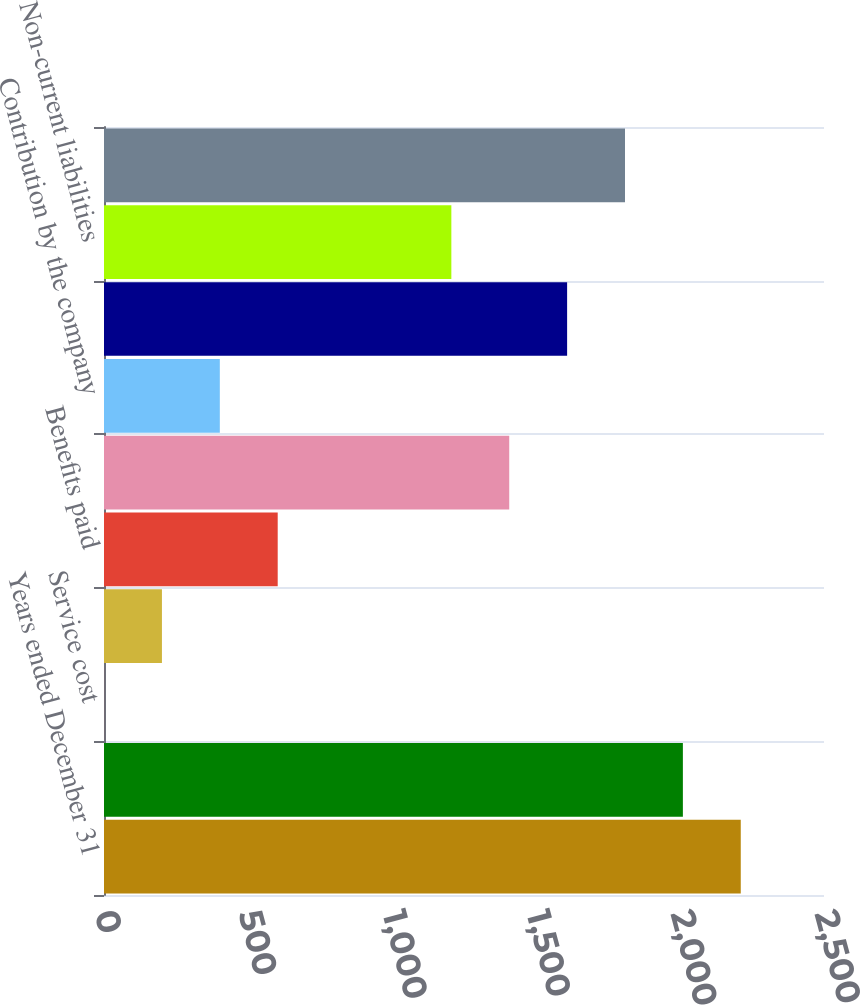Convert chart. <chart><loc_0><loc_0><loc_500><loc_500><bar_chart><fcel>Years ended December 31<fcel>PBO at beginning of year<fcel>Service cost<fcel>Interest cost<fcel>Benefits paid<fcel>PBO at end of year<fcel>Contribution by the company<fcel>Funded status<fcel>Non-current liabilities<fcel>Net pension liability at end<nl><fcel>2210.98<fcel>2010<fcel>0.2<fcel>201.18<fcel>603.14<fcel>1407.06<fcel>402.16<fcel>1608.04<fcel>1206.08<fcel>1809.02<nl></chart> 